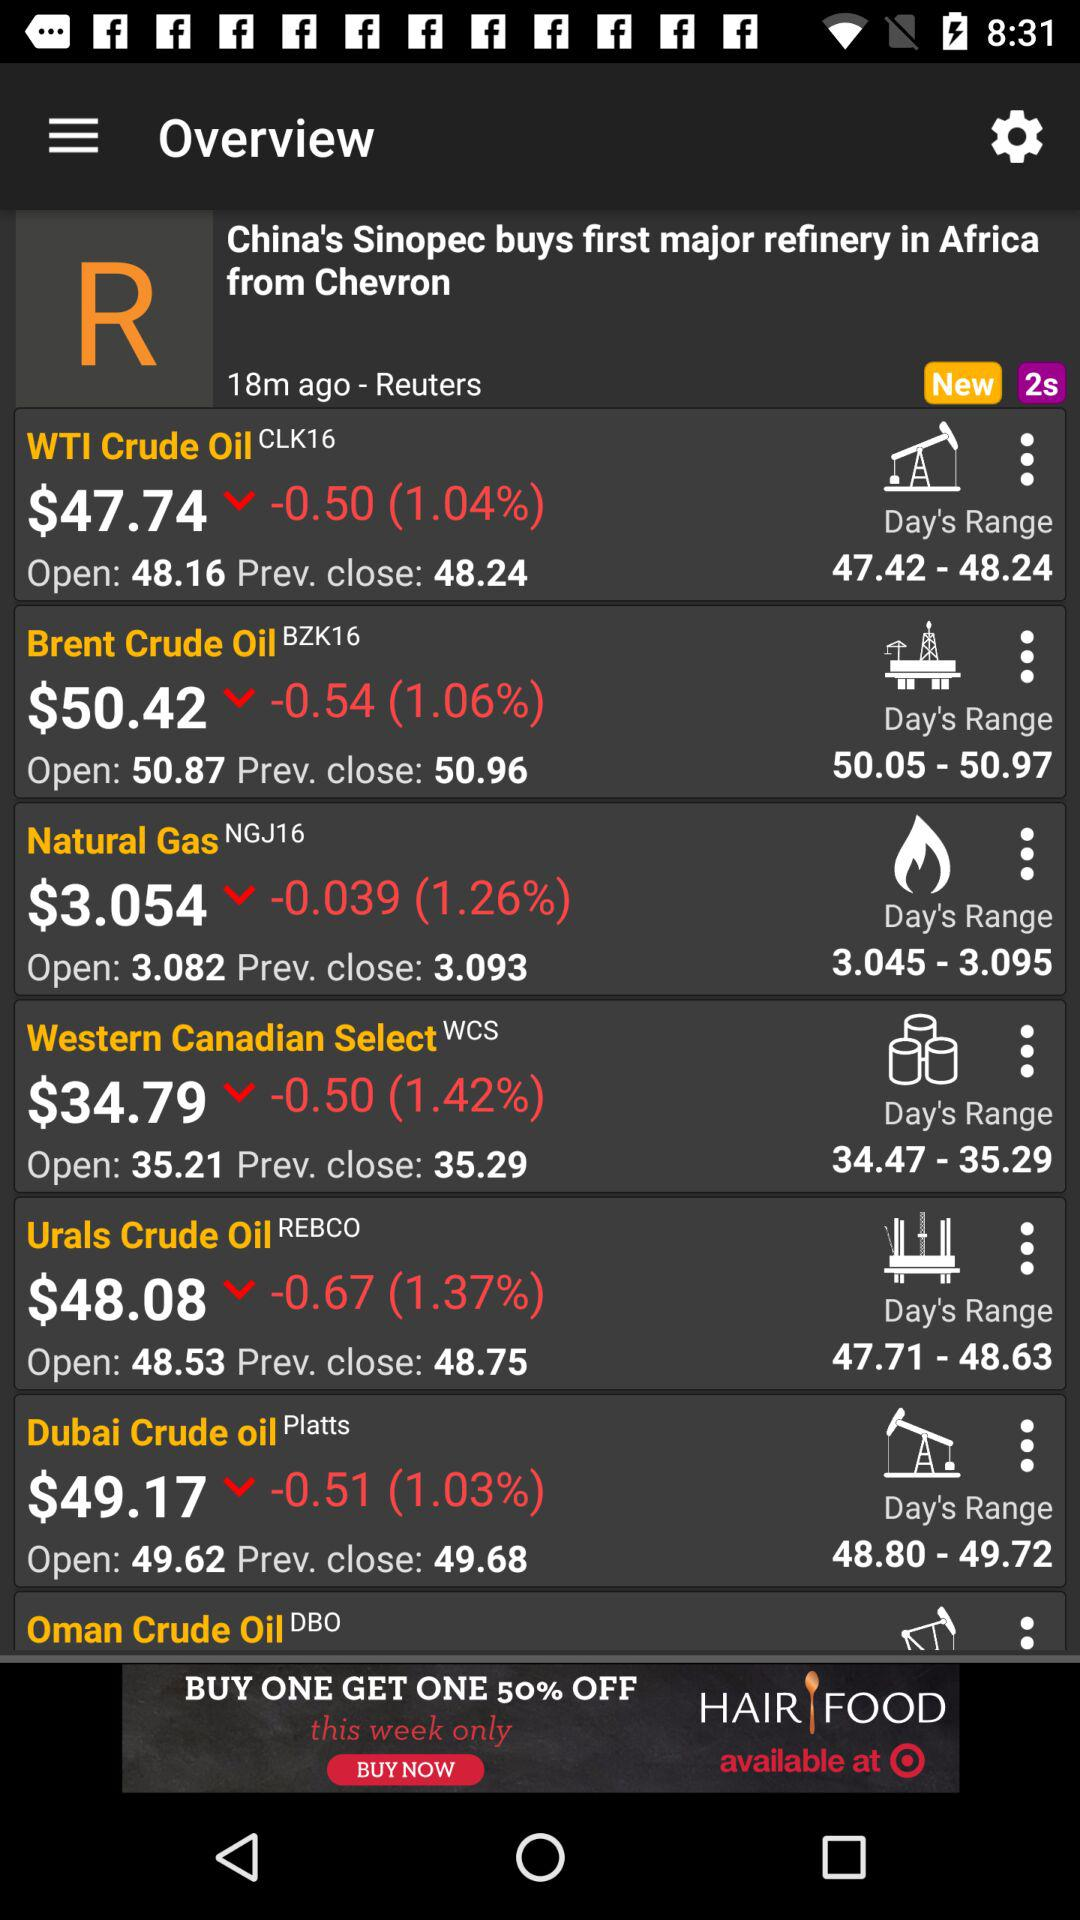When was the news posted? The news was posted 18 minutes ago. 